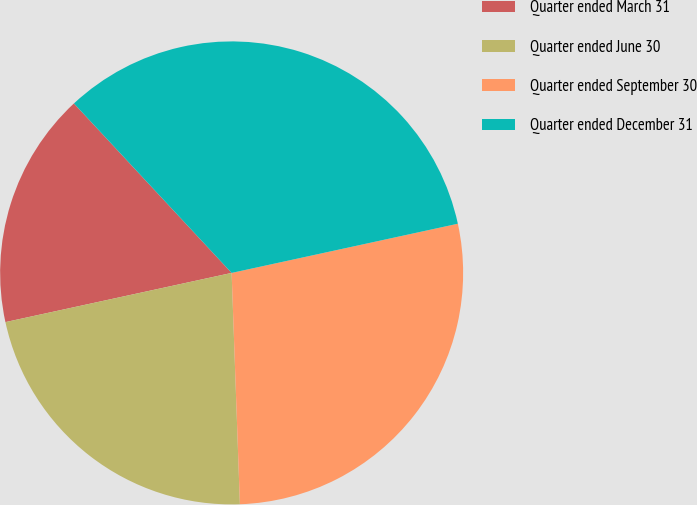<chart> <loc_0><loc_0><loc_500><loc_500><pie_chart><fcel>Quarter ended March 31<fcel>Quarter ended June 30<fcel>Quarter ended September 30<fcel>Quarter ended December 31<nl><fcel>16.48%<fcel>22.16%<fcel>27.84%<fcel>33.52%<nl></chart> 